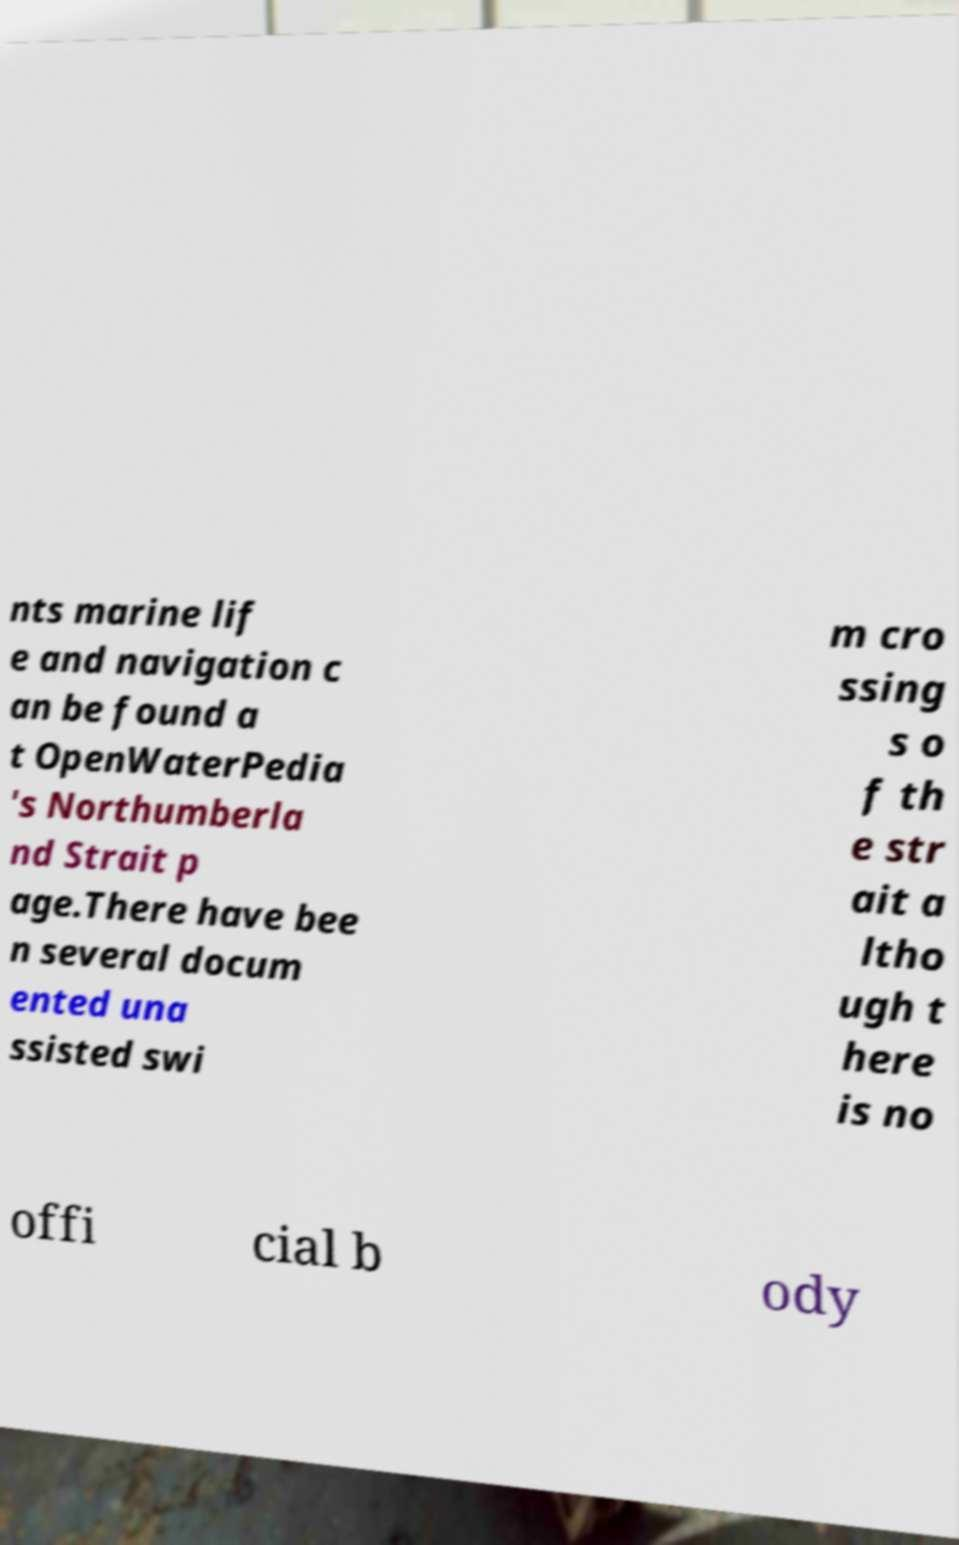What messages or text are displayed in this image? I need them in a readable, typed format. nts marine lif e and navigation c an be found a t OpenWaterPedia 's Northumberla nd Strait p age.There have bee n several docum ented una ssisted swi m cro ssing s o f th e str ait a ltho ugh t here is no offi cial b ody 